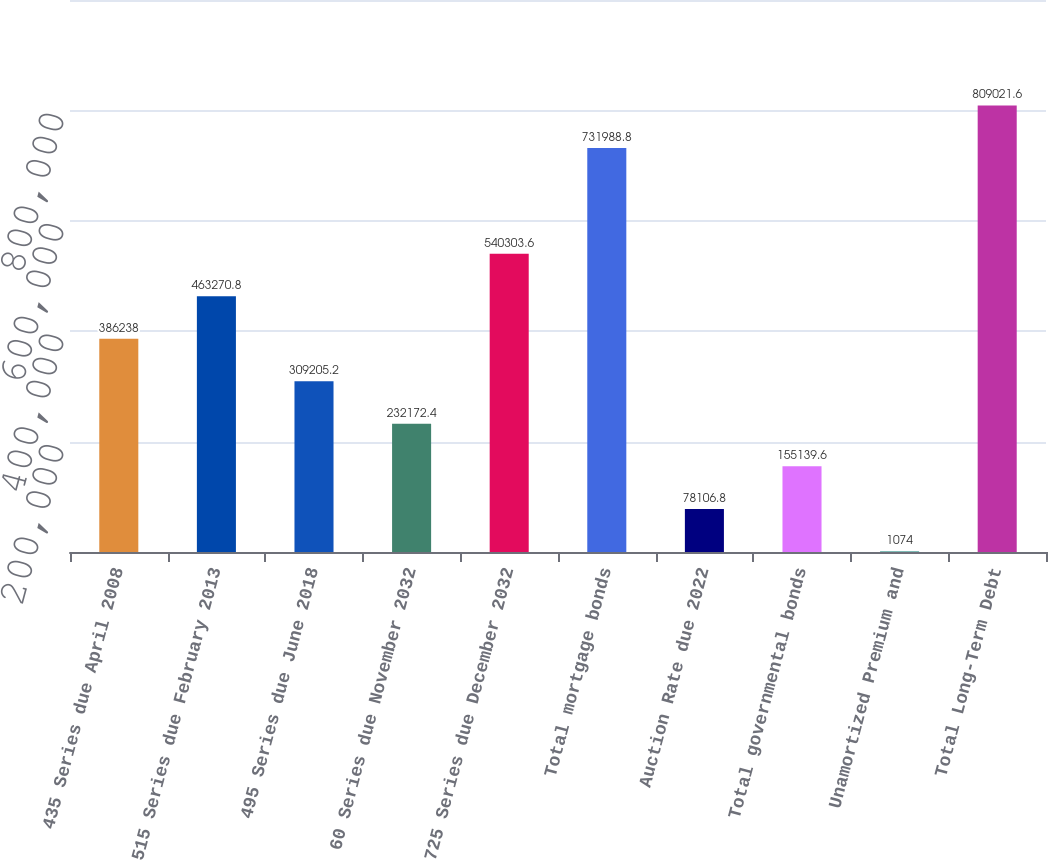Convert chart. <chart><loc_0><loc_0><loc_500><loc_500><bar_chart><fcel>435 Series due April 2008<fcel>515 Series due February 2013<fcel>495 Series due June 2018<fcel>60 Series due November 2032<fcel>725 Series due December 2032<fcel>Total mortgage bonds<fcel>Auction Rate due 2022<fcel>Total governmental bonds<fcel>Unamortized Premium and<fcel>Total Long-Term Debt<nl><fcel>386238<fcel>463271<fcel>309205<fcel>232172<fcel>540304<fcel>731989<fcel>78106.8<fcel>155140<fcel>1074<fcel>809022<nl></chart> 